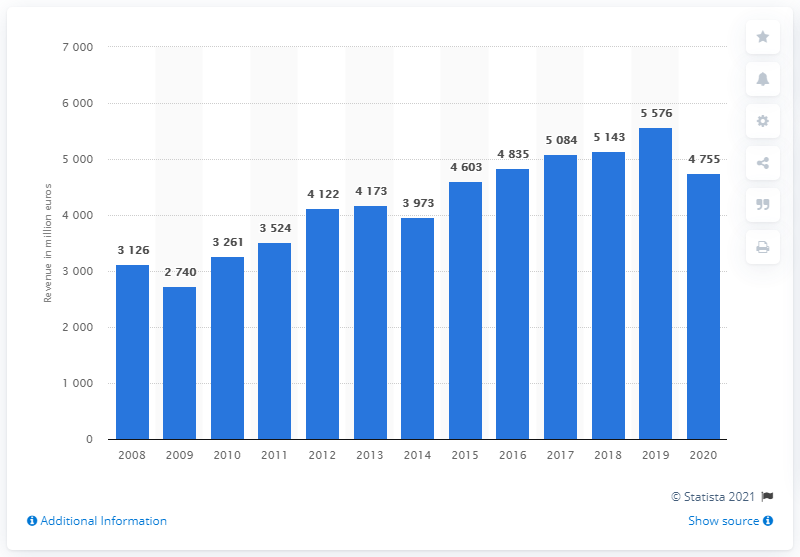Identify some key points in this picture. The revenue of LVMH's wine and spirits segment in 2020 was 4755. 